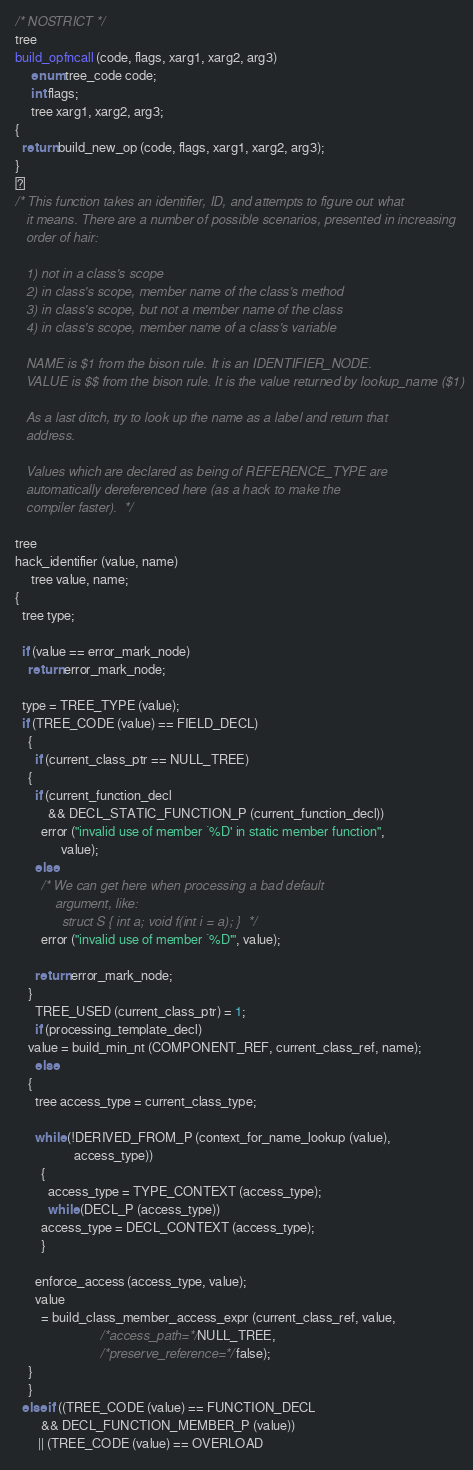<code> <loc_0><loc_0><loc_500><loc_500><_C_>
/* NOSTRICT */
tree
build_opfncall (code, flags, xarg1, xarg2, arg3)
     enum tree_code code;
     int flags;
     tree xarg1, xarg2, arg3;
{
  return build_new_op (code, flags, xarg1, xarg2, arg3);
}

/* This function takes an identifier, ID, and attempts to figure out what
   it means. There are a number of possible scenarios, presented in increasing
   order of hair:

   1) not in a class's scope
   2) in class's scope, member name of the class's method
   3) in class's scope, but not a member name of the class
   4) in class's scope, member name of a class's variable

   NAME is $1 from the bison rule. It is an IDENTIFIER_NODE.
   VALUE is $$ from the bison rule. It is the value returned by lookup_name ($1)

   As a last ditch, try to look up the name as a label and return that
   address.

   Values which are declared as being of REFERENCE_TYPE are
   automatically dereferenced here (as a hack to make the
   compiler faster).  */

tree
hack_identifier (value, name)
     tree value, name;
{
  tree type;

  if (value == error_mark_node)
    return error_mark_node;

  type = TREE_TYPE (value);
  if (TREE_CODE (value) == FIELD_DECL)
    {
      if (current_class_ptr == NULL_TREE)
	{
	  if (current_function_decl 
	      && DECL_STATIC_FUNCTION_P (current_function_decl))
	    error ("invalid use of member `%D' in static member function",
		      value);
	  else
	    /* We can get here when processing a bad default
	       argument, like:
	         struct S { int a; void f(int i = a); }  */
	    error ("invalid use of member `%D'", value);

	  return error_mark_node;
	}
      TREE_USED (current_class_ptr) = 1;
      if (processing_template_decl)
	value = build_min_nt (COMPONENT_REF, current_class_ref, name);
      else
	{
	  tree access_type = current_class_type;
	  
	  while (!DERIVED_FROM_P (context_for_name_lookup (value), 
				  access_type))
	    {
	      access_type = TYPE_CONTEXT (access_type);
	      while (DECL_P (access_type))
		access_type = DECL_CONTEXT (access_type);
	    }

	  enforce_access (access_type, value);
	  value 
	    = build_class_member_access_expr (current_class_ref, value,
					      /*access_path=*/NULL_TREE,
					      /*preserve_reference=*/false);
	}
    }
  else if ((TREE_CODE (value) == FUNCTION_DECL
	    && DECL_FUNCTION_MEMBER_P (value))
	   || (TREE_CODE (value) == OVERLOAD</code> 